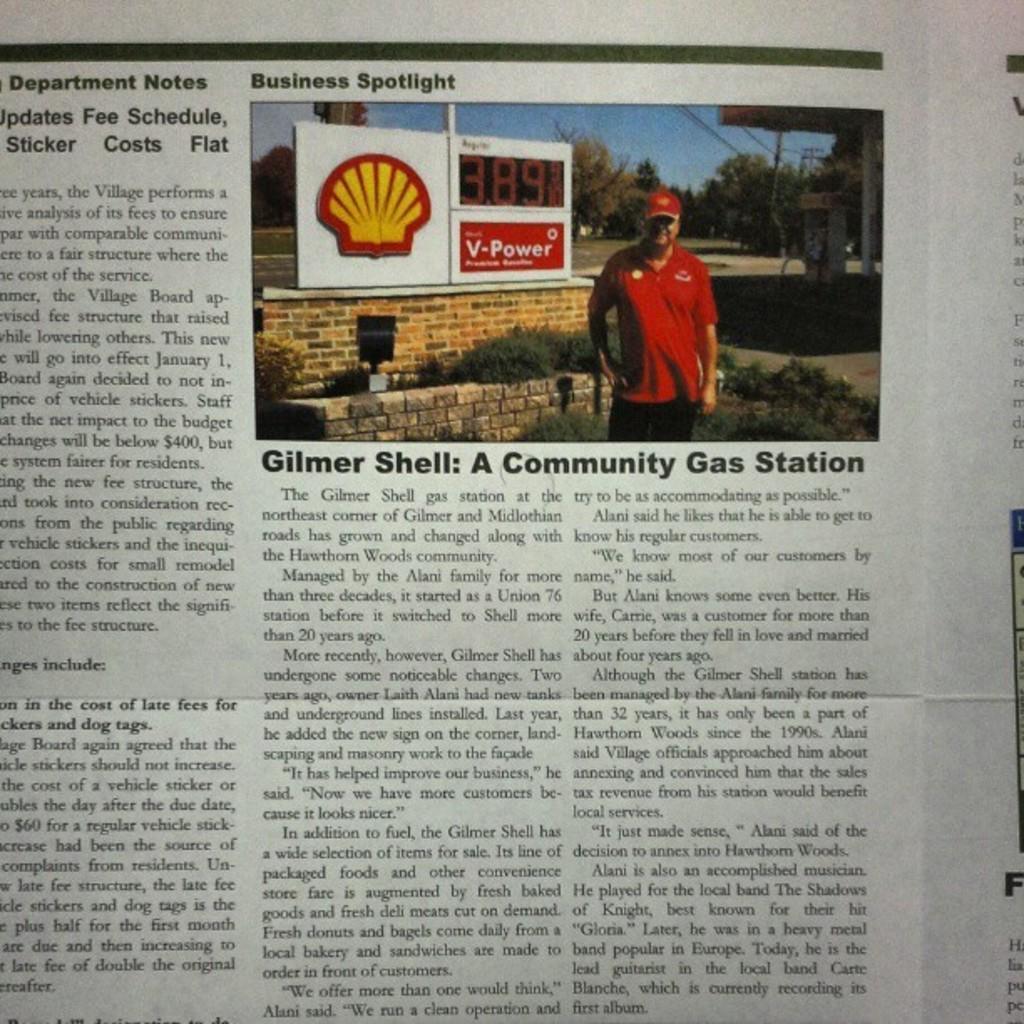Can you describe this image briefly? In this picture, we see a man in the red T-shirt and a red cap is standing. Behind him, we see the shrubs, walls and a board in white color with some text written on it. There are trees and a building in the background. At the bottom, we see some text written on the paper. This picture might be taken from the newspaper. 